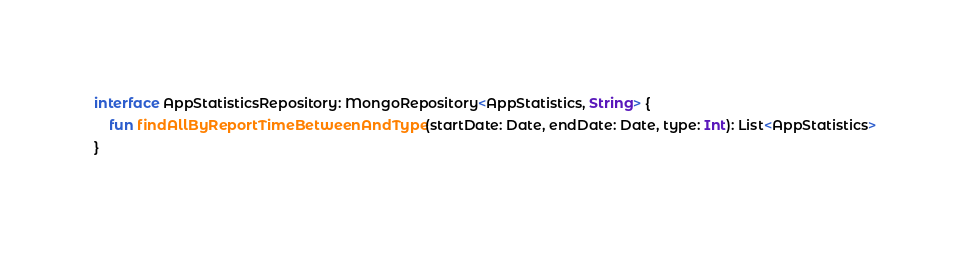<code> <loc_0><loc_0><loc_500><loc_500><_Kotlin_>
interface AppStatisticsRepository: MongoRepository<AppStatistics, String> {
    fun findAllByReportTimeBetweenAndType(startDate: Date, endDate: Date, type: Int): List<AppStatistics>
}</code> 